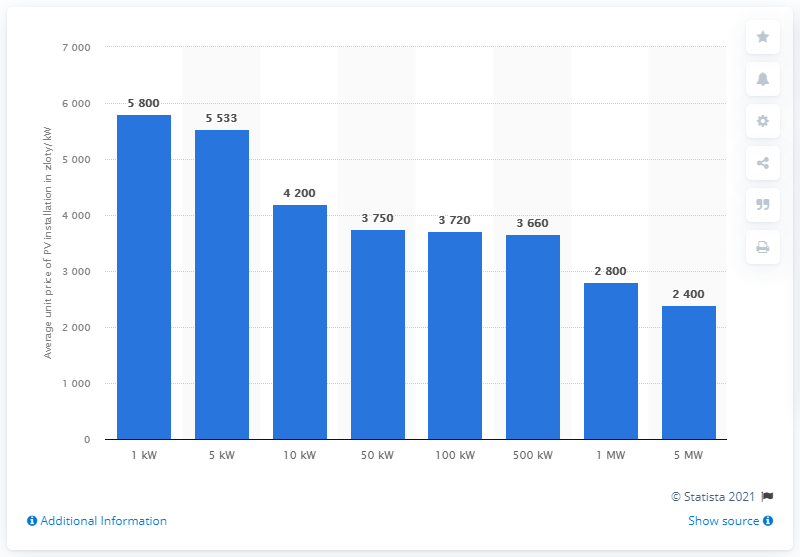Outline some significant characteristics in this image. In 2020, the average cost of a photovoltaic installation in Poland was approximately 5,533. 